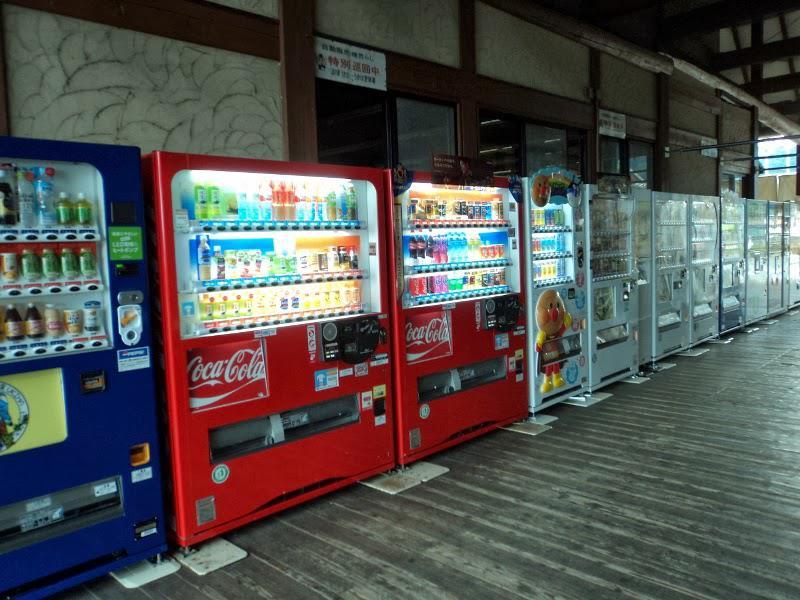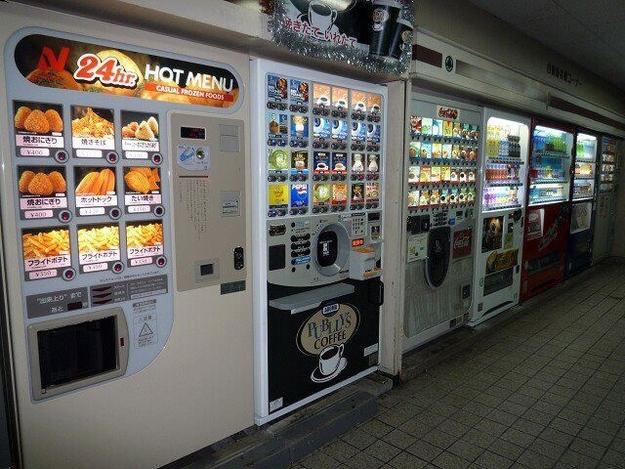The first image is the image on the left, the second image is the image on the right. Evaluate the accuracy of this statement regarding the images: "A blue vending machine and a red vending machine are side by side.". Is it true? Answer yes or no. Yes. The first image is the image on the left, the second image is the image on the right. Considering the images on both sides, is "One of the images clearly shows a blue vending machine placed directly next to a red vending machine." valid? Answer yes or no. Yes. 